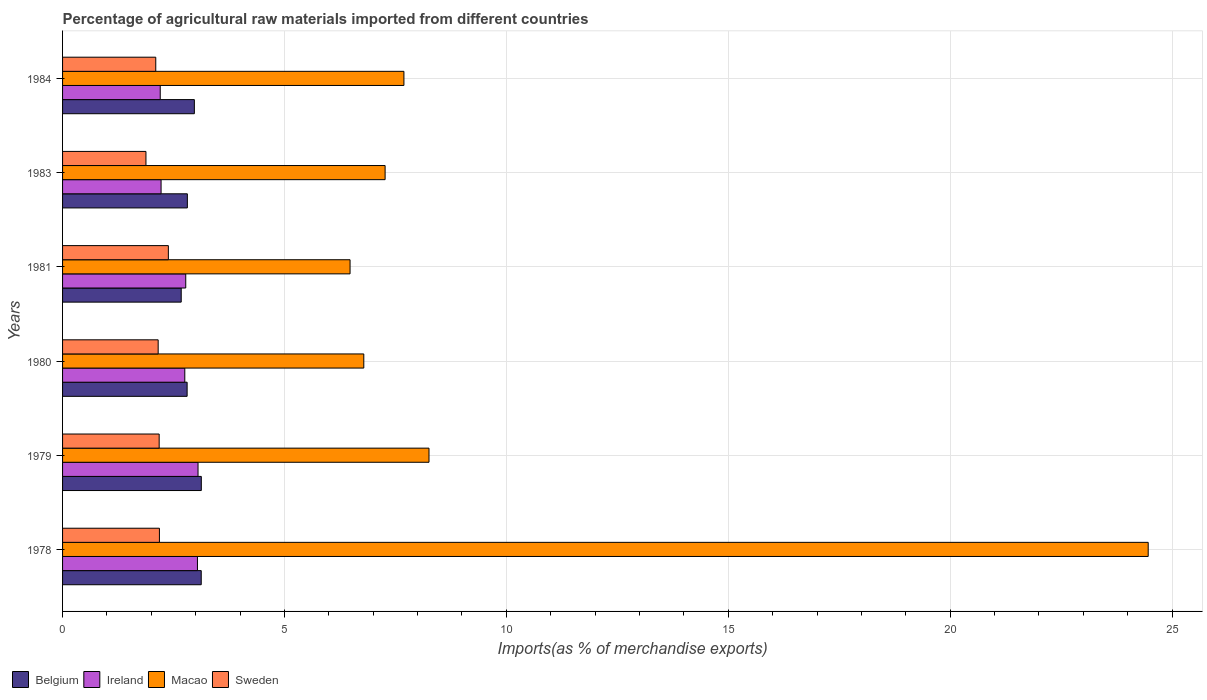How many different coloured bars are there?
Provide a short and direct response. 4. How many groups of bars are there?
Give a very brief answer. 6. Are the number of bars per tick equal to the number of legend labels?
Your response must be concise. Yes. Are the number of bars on each tick of the Y-axis equal?
Provide a short and direct response. Yes. What is the label of the 1st group of bars from the top?
Give a very brief answer. 1984. In how many cases, is the number of bars for a given year not equal to the number of legend labels?
Offer a terse response. 0. What is the percentage of imports to different countries in Macao in 1984?
Provide a short and direct response. 7.69. Across all years, what is the maximum percentage of imports to different countries in Belgium?
Offer a terse response. 3.13. Across all years, what is the minimum percentage of imports to different countries in Belgium?
Offer a terse response. 2.67. In which year was the percentage of imports to different countries in Belgium maximum?
Provide a short and direct response. 1979. In which year was the percentage of imports to different countries in Sweden minimum?
Provide a short and direct response. 1983. What is the total percentage of imports to different countries in Macao in the graph?
Offer a terse response. 60.94. What is the difference between the percentage of imports to different countries in Belgium in 1979 and that in 1980?
Your answer should be compact. 0.32. What is the difference between the percentage of imports to different countries in Macao in 1979 and the percentage of imports to different countries in Belgium in 1980?
Your response must be concise. 5.45. What is the average percentage of imports to different countries in Macao per year?
Ensure brevity in your answer.  10.16. In the year 1979, what is the difference between the percentage of imports to different countries in Belgium and percentage of imports to different countries in Ireland?
Give a very brief answer. 0.07. In how many years, is the percentage of imports to different countries in Macao greater than 21 %?
Ensure brevity in your answer.  1. What is the ratio of the percentage of imports to different countries in Ireland in 1978 to that in 1984?
Offer a terse response. 1.38. Is the percentage of imports to different countries in Ireland in 1979 less than that in 1980?
Provide a succinct answer. No. What is the difference between the highest and the second highest percentage of imports to different countries in Macao?
Your response must be concise. 16.21. What is the difference between the highest and the lowest percentage of imports to different countries in Sweden?
Give a very brief answer. 0.51. What does the 1st bar from the top in 1981 represents?
Keep it short and to the point. Sweden. What is the difference between two consecutive major ticks on the X-axis?
Offer a terse response. 5. Where does the legend appear in the graph?
Keep it short and to the point. Bottom left. What is the title of the graph?
Provide a succinct answer. Percentage of agricultural raw materials imported from different countries. What is the label or title of the X-axis?
Offer a terse response. Imports(as % of merchandise exports). What is the Imports(as % of merchandise exports) in Belgium in 1978?
Your answer should be compact. 3.12. What is the Imports(as % of merchandise exports) of Ireland in 1978?
Provide a succinct answer. 3.04. What is the Imports(as % of merchandise exports) in Macao in 1978?
Your answer should be very brief. 24.46. What is the Imports(as % of merchandise exports) in Sweden in 1978?
Make the answer very short. 2.18. What is the Imports(as % of merchandise exports) in Belgium in 1979?
Give a very brief answer. 3.13. What is the Imports(as % of merchandise exports) in Ireland in 1979?
Provide a succinct answer. 3.05. What is the Imports(as % of merchandise exports) in Macao in 1979?
Make the answer very short. 8.26. What is the Imports(as % of merchandise exports) in Sweden in 1979?
Keep it short and to the point. 2.18. What is the Imports(as % of merchandise exports) in Belgium in 1980?
Your response must be concise. 2.81. What is the Imports(as % of merchandise exports) of Ireland in 1980?
Give a very brief answer. 2.75. What is the Imports(as % of merchandise exports) in Macao in 1980?
Your answer should be very brief. 6.79. What is the Imports(as % of merchandise exports) in Sweden in 1980?
Provide a short and direct response. 2.15. What is the Imports(as % of merchandise exports) in Belgium in 1981?
Your answer should be very brief. 2.67. What is the Imports(as % of merchandise exports) of Ireland in 1981?
Your answer should be compact. 2.78. What is the Imports(as % of merchandise exports) of Macao in 1981?
Make the answer very short. 6.48. What is the Imports(as % of merchandise exports) in Sweden in 1981?
Your answer should be compact. 2.38. What is the Imports(as % of merchandise exports) in Belgium in 1983?
Offer a very short reply. 2.81. What is the Imports(as % of merchandise exports) in Ireland in 1983?
Keep it short and to the point. 2.22. What is the Imports(as % of merchandise exports) in Macao in 1983?
Provide a succinct answer. 7.27. What is the Imports(as % of merchandise exports) in Sweden in 1983?
Make the answer very short. 1.88. What is the Imports(as % of merchandise exports) of Belgium in 1984?
Ensure brevity in your answer.  2.97. What is the Imports(as % of merchandise exports) in Ireland in 1984?
Your answer should be very brief. 2.2. What is the Imports(as % of merchandise exports) in Macao in 1984?
Offer a terse response. 7.69. What is the Imports(as % of merchandise exports) of Sweden in 1984?
Your answer should be very brief. 2.1. Across all years, what is the maximum Imports(as % of merchandise exports) of Belgium?
Keep it short and to the point. 3.13. Across all years, what is the maximum Imports(as % of merchandise exports) in Ireland?
Offer a terse response. 3.05. Across all years, what is the maximum Imports(as % of merchandise exports) of Macao?
Offer a terse response. 24.46. Across all years, what is the maximum Imports(as % of merchandise exports) in Sweden?
Keep it short and to the point. 2.38. Across all years, what is the minimum Imports(as % of merchandise exports) of Belgium?
Offer a terse response. 2.67. Across all years, what is the minimum Imports(as % of merchandise exports) in Ireland?
Offer a terse response. 2.2. Across all years, what is the minimum Imports(as % of merchandise exports) of Macao?
Your answer should be very brief. 6.48. Across all years, what is the minimum Imports(as % of merchandise exports) of Sweden?
Ensure brevity in your answer.  1.88. What is the total Imports(as % of merchandise exports) of Belgium in the graph?
Provide a succinct answer. 17.51. What is the total Imports(as % of merchandise exports) in Ireland in the graph?
Your answer should be compact. 16.04. What is the total Imports(as % of merchandise exports) in Macao in the graph?
Keep it short and to the point. 60.94. What is the total Imports(as % of merchandise exports) in Sweden in the graph?
Ensure brevity in your answer.  12.88. What is the difference between the Imports(as % of merchandise exports) of Belgium in 1978 and that in 1979?
Your answer should be very brief. -0. What is the difference between the Imports(as % of merchandise exports) of Ireland in 1978 and that in 1979?
Your answer should be very brief. -0.01. What is the difference between the Imports(as % of merchandise exports) in Macao in 1978 and that in 1979?
Keep it short and to the point. 16.21. What is the difference between the Imports(as % of merchandise exports) of Sweden in 1978 and that in 1979?
Provide a short and direct response. 0.01. What is the difference between the Imports(as % of merchandise exports) of Belgium in 1978 and that in 1980?
Ensure brevity in your answer.  0.32. What is the difference between the Imports(as % of merchandise exports) of Ireland in 1978 and that in 1980?
Provide a succinct answer. 0.29. What is the difference between the Imports(as % of merchandise exports) of Macao in 1978 and that in 1980?
Give a very brief answer. 17.67. What is the difference between the Imports(as % of merchandise exports) of Sweden in 1978 and that in 1980?
Make the answer very short. 0.03. What is the difference between the Imports(as % of merchandise exports) of Belgium in 1978 and that in 1981?
Provide a succinct answer. 0.45. What is the difference between the Imports(as % of merchandise exports) of Ireland in 1978 and that in 1981?
Offer a very short reply. 0.26. What is the difference between the Imports(as % of merchandise exports) of Macao in 1978 and that in 1981?
Make the answer very short. 17.98. What is the difference between the Imports(as % of merchandise exports) in Sweden in 1978 and that in 1981?
Offer a very short reply. -0.2. What is the difference between the Imports(as % of merchandise exports) of Belgium in 1978 and that in 1983?
Your answer should be very brief. 0.31. What is the difference between the Imports(as % of merchandise exports) in Ireland in 1978 and that in 1983?
Provide a short and direct response. 0.82. What is the difference between the Imports(as % of merchandise exports) of Macao in 1978 and that in 1983?
Your answer should be very brief. 17.19. What is the difference between the Imports(as % of merchandise exports) in Sweden in 1978 and that in 1983?
Your response must be concise. 0.3. What is the difference between the Imports(as % of merchandise exports) of Belgium in 1978 and that in 1984?
Keep it short and to the point. 0.15. What is the difference between the Imports(as % of merchandise exports) of Ireland in 1978 and that in 1984?
Make the answer very short. 0.84. What is the difference between the Imports(as % of merchandise exports) in Macao in 1978 and that in 1984?
Your answer should be compact. 16.77. What is the difference between the Imports(as % of merchandise exports) in Sweden in 1978 and that in 1984?
Provide a short and direct response. 0.08. What is the difference between the Imports(as % of merchandise exports) in Belgium in 1979 and that in 1980?
Ensure brevity in your answer.  0.32. What is the difference between the Imports(as % of merchandise exports) of Ireland in 1979 and that in 1980?
Give a very brief answer. 0.3. What is the difference between the Imports(as % of merchandise exports) of Macao in 1979 and that in 1980?
Keep it short and to the point. 1.47. What is the difference between the Imports(as % of merchandise exports) of Sweden in 1979 and that in 1980?
Your response must be concise. 0.02. What is the difference between the Imports(as % of merchandise exports) in Belgium in 1979 and that in 1981?
Offer a very short reply. 0.45. What is the difference between the Imports(as % of merchandise exports) in Ireland in 1979 and that in 1981?
Your answer should be compact. 0.28. What is the difference between the Imports(as % of merchandise exports) in Macao in 1979 and that in 1981?
Make the answer very short. 1.78. What is the difference between the Imports(as % of merchandise exports) of Sweden in 1979 and that in 1981?
Your answer should be very brief. -0.21. What is the difference between the Imports(as % of merchandise exports) in Belgium in 1979 and that in 1983?
Offer a terse response. 0.31. What is the difference between the Imports(as % of merchandise exports) of Ireland in 1979 and that in 1983?
Offer a very short reply. 0.83. What is the difference between the Imports(as % of merchandise exports) of Sweden in 1979 and that in 1983?
Provide a short and direct response. 0.3. What is the difference between the Imports(as % of merchandise exports) in Belgium in 1979 and that in 1984?
Your answer should be compact. 0.16. What is the difference between the Imports(as % of merchandise exports) in Ireland in 1979 and that in 1984?
Ensure brevity in your answer.  0.85. What is the difference between the Imports(as % of merchandise exports) in Macao in 1979 and that in 1984?
Your response must be concise. 0.57. What is the difference between the Imports(as % of merchandise exports) of Sweden in 1979 and that in 1984?
Offer a terse response. 0.08. What is the difference between the Imports(as % of merchandise exports) in Belgium in 1980 and that in 1981?
Keep it short and to the point. 0.13. What is the difference between the Imports(as % of merchandise exports) in Ireland in 1980 and that in 1981?
Offer a terse response. -0.02. What is the difference between the Imports(as % of merchandise exports) in Macao in 1980 and that in 1981?
Your answer should be compact. 0.31. What is the difference between the Imports(as % of merchandise exports) of Sweden in 1980 and that in 1981?
Offer a terse response. -0.23. What is the difference between the Imports(as % of merchandise exports) in Belgium in 1980 and that in 1983?
Give a very brief answer. -0.01. What is the difference between the Imports(as % of merchandise exports) in Ireland in 1980 and that in 1983?
Ensure brevity in your answer.  0.53. What is the difference between the Imports(as % of merchandise exports) in Macao in 1980 and that in 1983?
Keep it short and to the point. -0.48. What is the difference between the Imports(as % of merchandise exports) in Sweden in 1980 and that in 1983?
Your answer should be very brief. 0.28. What is the difference between the Imports(as % of merchandise exports) of Belgium in 1980 and that in 1984?
Provide a short and direct response. -0.16. What is the difference between the Imports(as % of merchandise exports) in Ireland in 1980 and that in 1984?
Your response must be concise. 0.55. What is the difference between the Imports(as % of merchandise exports) of Macao in 1980 and that in 1984?
Ensure brevity in your answer.  -0.9. What is the difference between the Imports(as % of merchandise exports) of Sweden in 1980 and that in 1984?
Your answer should be compact. 0.05. What is the difference between the Imports(as % of merchandise exports) in Belgium in 1981 and that in 1983?
Offer a terse response. -0.14. What is the difference between the Imports(as % of merchandise exports) of Ireland in 1981 and that in 1983?
Keep it short and to the point. 0.56. What is the difference between the Imports(as % of merchandise exports) in Macao in 1981 and that in 1983?
Your answer should be very brief. -0.79. What is the difference between the Imports(as % of merchandise exports) of Sweden in 1981 and that in 1983?
Give a very brief answer. 0.51. What is the difference between the Imports(as % of merchandise exports) in Belgium in 1981 and that in 1984?
Give a very brief answer. -0.3. What is the difference between the Imports(as % of merchandise exports) of Ireland in 1981 and that in 1984?
Provide a short and direct response. 0.58. What is the difference between the Imports(as % of merchandise exports) of Macao in 1981 and that in 1984?
Make the answer very short. -1.21. What is the difference between the Imports(as % of merchandise exports) in Sweden in 1981 and that in 1984?
Your response must be concise. 0.28. What is the difference between the Imports(as % of merchandise exports) of Belgium in 1983 and that in 1984?
Offer a very short reply. -0.16. What is the difference between the Imports(as % of merchandise exports) of Ireland in 1983 and that in 1984?
Your response must be concise. 0.02. What is the difference between the Imports(as % of merchandise exports) in Macao in 1983 and that in 1984?
Keep it short and to the point. -0.42. What is the difference between the Imports(as % of merchandise exports) in Sweden in 1983 and that in 1984?
Offer a terse response. -0.22. What is the difference between the Imports(as % of merchandise exports) of Belgium in 1978 and the Imports(as % of merchandise exports) of Ireland in 1979?
Ensure brevity in your answer.  0.07. What is the difference between the Imports(as % of merchandise exports) of Belgium in 1978 and the Imports(as % of merchandise exports) of Macao in 1979?
Make the answer very short. -5.13. What is the difference between the Imports(as % of merchandise exports) in Belgium in 1978 and the Imports(as % of merchandise exports) in Sweden in 1979?
Keep it short and to the point. 0.95. What is the difference between the Imports(as % of merchandise exports) in Ireland in 1978 and the Imports(as % of merchandise exports) in Macao in 1979?
Provide a short and direct response. -5.22. What is the difference between the Imports(as % of merchandise exports) in Ireland in 1978 and the Imports(as % of merchandise exports) in Sweden in 1979?
Give a very brief answer. 0.86. What is the difference between the Imports(as % of merchandise exports) of Macao in 1978 and the Imports(as % of merchandise exports) of Sweden in 1979?
Ensure brevity in your answer.  22.29. What is the difference between the Imports(as % of merchandise exports) in Belgium in 1978 and the Imports(as % of merchandise exports) in Ireland in 1980?
Provide a succinct answer. 0.37. What is the difference between the Imports(as % of merchandise exports) in Belgium in 1978 and the Imports(as % of merchandise exports) in Macao in 1980?
Your answer should be compact. -3.66. What is the difference between the Imports(as % of merchandise exports) in Belgium in 1978 and the Imports(as % of merchandise exports) in Sweden in 1980?
Your answer should be very brief. 0.97. What is the difference between the Imports(as % of merchandise exports) of Ireland in 1978 and the Imports(as % of merchandise exports) of Macao in 1980?
Offer a terse response. -3.75. What is the difference between the Imports(as % of merchandise exports) in Ireland in 1978 and the Imports(as % of merchandise exports) in Sweden in 1980?
Offer a terse response. 0.89. What is the difference between the Imports(as % of merchandise exports) in Macao in 1978 and the Imports(as % of merchandise exports) in Sweden in 1980?
Keep it short and to the point. 22.31. What is the difference between the Imports(as % of merchandise exports) of Belgium in 1978 and the Imports(as % of merchandise exports) of Ireland in 1981?
Provide a short and direct response. 0.35. What is the difference between the Imports(as % of merchandise exports) in Belgium in 1978 and the Imports(as % of merchandise exports) in Macao in 1981?
Ensure brevity in your answer.  -3.35. What is the difference between the Imports(as % of merchandise exports) of Belgium in 1978 and the Imports(as % of merchandise exports) of Sweden in 1981?
Your answer should be very brief. 0.74. What is the difference between the Imports(as % of merchandise exports) of Ireland in 1978 and the Imports(as % of merchandise exports) of Macao in 1981?
Your answer should be compact. -3.44. What is the difference between the Imports(as % of merchandise exports) in Ireland in 1978 and the Imports(as % of merchandise exports) in Sweden in 1981?
Make the answer very short. 0.66. What is the difference between the Imports(as % of merchandise exports) in Macao in 1978 and the Imports(as % of merchandise exports) in Sweden in 1981?
Ensure brevity in your answer.  22.08. What is the difference between the Imports(as % of merchandise exports) of Belgium in 1978 and the Imports(as % of merchandise exports) of Ireland in 1983?
Make the answer very short. 0.9. What is the difference between the Imports(as % of merchandise exports) in Belgium in 1978 and the Imports(as % of merchandise exports) in Macao in 1983?
Make the answer very short. -4.14. What is the difference between the Imports(as % of merchandise exports) of Belgium in 1978 and the Imports(as % of merchandise exports) of Sweden in 1983?
Ensure brevity in your answer.  1.25. What is the difference between the Imports(as % of merchandise exports) in Ireland in 1978 and the Imports(as % of merchandise exports) in Macao in 1983?
Give a very brief answer. -4.23. What is the difference between the Imports(as % of merchandise exports) in Ireland in 1978 and the Imports(as % of merchandise exports) in Sweden in 1983?
Keep it short and to the point. 1.16. What is the difference between the Imports(as % of merchandise exports) of Macao in 1978 and the Imports(as % of merchandise exports) of Sweden in 1983?
Keep it short and to the point. 22.58. What is the difference between the Imports(as % of merchandise exports) of Belgium in 1978 and the Imports(as % of merchandise exports) of Ireland in 1984?
Provide a succinct answer. 0.92. What is the difference between the Imports(as % of merchandise exports) of Belgium in 1978 and the Imports(as % of merchandise exports) of Macao in 1984?
Your answer should be very brief. -4.57. What is the difference between the Imports(as % of merchandise exports) of Belgium in 1978 and the Imports(as % of merchandise exports) of Sweden in 1984?
Give a very brief answer. 1.02. What is the difference between the Imports(as % of merchandise exports) of Ireland in 1978 and the Imports(as % of merchandise exports) of Macao in 1984?
Make the answer very short. -4.65. What is the difference between the Imports(as % of merchandise exports) in Ireland in 1978 and the Imports(as % of merchandise exports) in Sweden in 1984?
Provide a succinct answer. 0.94. What is the difference between the Imports(as % of merchandise exports) of Macao in 1978 and the Imports(as % of merchandise exports) of Sweden in 1984?
Offer a terse response. 22.36. What is the difference between the Imports(as % of merchandise exports) of Belgium in 1979 and the Imports(as % of merchandise exports) of Ireland in 1980?
Your response must be concise. 0.37. What is the difference between the Imports(as % of merchandise exports) of Belgium in 1979 and the Imports(as % of merchandise exports) of Macao in 1980?
Make the answer very short. -3.66. What is the difference between the Imports(as % of merchandise exports) of Belgium in 1979 and the Imports(as % of merchandise exports) of Sweden in 1980?
Provide a succinct answer. 0.97. What is the difference between the Imports(as % of merchandise exports) in Ireland in 1979 and the Imports(as % of merchandise exports) in Macao in 1980?
Offer a very short reply. -3.74. What is the difference between the Imports(as % of merchandise exports) of Ireland in 1979 and the Imports(as % of merchandise exports) of Sweden in 1980?
Make the answer very short. 0.9. What is the difference between the Imports(as % of merchandise exports) of Macao in 1979 and the Imports(as % of merchandise exports) of Sweden in 1980?
Offer a terse response. 6.1. What is the difference between the Imports(as % of merchandise exports) in Belgium in 1979 and the Imports(as % of merchandise exports) in Ireland in 1981?
Your answer should be very brief. 0.35. What is the difference between the Imports(as % of merchandise exports) of Belgium in 1979 and the Imports(as % of merchandise exports) of Macao in 1981?
Your answer should be compact. -3.35. What is the difference between the Imports(as % of merchandise exports) in Belgium in 1979 and the Imports(as % of merchandise exports) in Sweden in 1981?
Give a very brief answer. 0.74. What is the difference between the Imports(as % of merchandise exports) of Ireland in 1979 and the Imports(as % of merchandise exports) of Macao in 1981?
Keep it short and to the point. -3.43. What is the difference between the Imports(as % of merchandise exports) of Ireland in 1979 and the Imports(as % of merchandise exports) of Sweden in 1981?
Your response must be concise. 0.67. What is the difference between the Imports(as % of merchandise exports) of Macao in 1979 and the Imports(as % of merchandise exports) of Sweden in 1981?
Provide a succinct answer. 5.87. What is the difference between the Imports(as % of merchandise exports) in Belgium in 1979 and the Imports(as % of merchandise exports) in Ireland in 1983?
Your answer should be very brief. 0.91. What is the difference between the Imports(as % of merchandise exports) in Belgium in 1979 and the Imports(as % of merchandise exports) in Macao in 1983?
Your answer should be compact. -4.14. What is the difference between the Imports(as % of merchandise exports) of Belgium in 1979 and the Imports(as % of merchandise exports) of Sweden in 1983?
Offer a very short reply. 1.25. What is the difference between the Imports(as % of merchandise exports) of Ireland in 1979 and the Imports(as % of merchandise exports) of Macao in 1983?
Offer a terse response. -4.22. What is the difference between the Imports(as % of merchandise exports) of Ireland in 1979 and the Imports(as % of merchandise exports) of Sweden in 1983?
Your answer should be compact. 1.17. What is the difference between the Imports(as % of merchandise exports) of Macao in 1979 and the Imports(as % of merchandise exports) of Sweden in 1983?
Keep it short and to the point. 6.38. What is the difference between the Imports(as % of merchandise exports) in Belgium in 1979 and the Imports(as % of merchandise exports) in Ireland in 1984?
Make the answer very short. 0.93. What is the difference between the Imports(as % of merchandise exports) of Belgium in 1979 and the Imports(as % of merchandise exports) of Macao in 1984?
Provide a succinct answer. -4.57. What is the difference between the Imports(as % of merchandise exports) of Belgium in 1979 and the Imports(as % of merchandise exports) of Sweden in 1984?
Ensure brevity in your answer.  1.03. What is the difference between the Imports(as % of merchandise exports) of Ireland in 1979 and the Imports(as % of merchandise exports) of Macao in 1984?
Keep it short and to the point. -4.64. What is the difference between the Imports(as % of merchandise exports) in Ireland in 1979 and the Imports(as % of merchandise exports) in Sweden in 1984?
Make the answer very short. 0.95. What is the difference between the Imports(as % of merchandise exports) in Macao in 1979 and the Imports(as % of merchandise exports) in Sweden in 1984?
Offer a terse response. 6.16. What is the difference between the Imports(as % of merchandise exports) of Belgium in 1980 and the Imports(as % of merchandise exports) of Ireland in 1981?
Provide a short and direct response. 0.03. What is the difference between the Imports(as % of merchandise exports) in Belgium in 1980 and the Imports(as % of merchandise exports) in Macao in 1981?
Offer a very short reply. -3.67. What is the difference between the Imports(as % of merchandise exports) of Belgium in 1980 and the Imports(as % of merchandise exports) of Sweden in 1981?
Give a very brief answer. 0.42. What is the difference between the Imports(as % of merchandise exports) of Ireland in 1980 and the Imports(as % of merchandise exports) of Macao in 1981?
Your answer should be very brief. -3.72. What is the difference between the Imports(as % of merchandise exports) of Ireland in 1980 and the Imports(as % of merchandise exports) of Sweden in 1981?
Provide a short and direct response. 0.37. What is the difference between the Imports(as % of merchandise exports) in Macao in 1980 and the Imports(as % of merchandise exports) in Sweden in 1981?
Provide a succinct answer. 4.4. What is the difference between the Imports(as % of merchandise exports) of Belgium in 1980 and the Imports(as % of merchandise exports) of Ireland in 1983?
Provide a succinct answer. 0.59. What is the difference between the Imports(as % of merchandise exports) of Belgium in 1980 and the Imports(as % of merchandise exports) of Macao in 1983?
Ensure brevity in your answer.  -4.46. What is the difference between the Imports(as % of merchandise exports) in Belgium in 1980 and the Imports(as % of merchandise exports) in Sweden in 1983?
Your answer should be very brief. 0.93. What is the difference between the Imports(as % of merchandise exports) in Ireland in 1980 and the Imports(as % of merchandise exports) in Macao in 1983?
Make the answer very short. -4.51. What is the difference between the Imports(as % of merchandise exports) in Ireland in 1980 and the Imports(as % of merchandise exports) in Sweden in 1983?
Keep it short and to the point. 0.88. What is the difference between the Imports(as % of merchandise exports) in Macao in 1980 and the Imports(as % of merchandise exports) in Sweden in 1983?
Offer a very short reply. 4.91. What is the difference between the Imports(as % of merchandise exports) of Belgium in 1980 and the Imports(as % of merchandise exports) of Ireland in 1984?
Make the answer very short. 0.61. What is the difference between the Imports(as % of merchandise exports) in Belgium in 1980 and the Imports(as % of merchandise exports) in Macao in 1984?
Provide a succinct answer. -4.88. What is the difference between the Imports(as % of merchandise exports) of Belgium in 1980 and the Imports(as % of merchandise exports) of Sweden in 1984?
Your response must be concise. 0.71. What is the difference between the Imports(as % of merchandise exports) in Ireland in 1980 and the Imports(as % of merchandise exports) in Macao in 1984?
Provide a succinct answer. -4.94. What is the difference between the Imports(as % of merchandise exports) of Ireland in 1980 and the Imports(as % of merchandise exports) of Sweden in 1984?
Offer a terse response. 0.65. What is the difference between the Imports(as % of merchandise exports) in Macao in 1980 and the Imports(as % of merchandise exports) in Sweden in 1984?
Your response must be concise. 4.69. What is the difference between the Imports(as % of merchandise exports) of Belgium in 1981 and the Imports(as % of merchandise exports) of Ireland in 1983?
Offer a terse response. 0.45. What is the difference between the Imports(as % of merchandise exports) in Belgium in 1981 and the Imports(as % of merchandise exports) in Macao in 1983?
Give a very brief answer. -4.59. What is the difference between the Imports(as % of merchandise exports) in Belgium in 1981 and the Imports(as % of merchandise exports) in Sweden in 1983?
Give a very brief answer. 0.79. What is the difference between the Imports(as % of merchandise exports) in Ireland in 1981 and the Imports(as % of merchandise exports) in Macao in 1983?
Offer a very short reply. -4.49. What is the difference between the Imports(as % of merchandise exports) of Ireland in 1981 and the Imports(as % of merchandise exports) of Sweden in 1983?
Your answer should be very brief. 0.9. What is the difference between the Imports(as % of merchandise exports) of Macao in 1981 and the Imports(as % of merchandise exports) of Sweden in 1983?
Offer a very short reply. 4.6. What is the difference between the Imports(as % of merchandise exports) of Belgium in 1981 and the Imports(as % of merchandise exports) of Ireland in 1984?
Make the answer very short. 0.47. What is the difference between the Imports(as % of merchandise exports) of Belgium in 1981 and the Imports(as % of merchandise exports) of Macao in 1984?
Offer a very short reply. -5.02. What is the difference between the Imports(as % of merchandise exports) of Belgium in 1981 and the Imports(as % of merchandise exports) of Sweden in 1984?
Make the answer very short. 0.57. What is the difference between the Imports(as % of merchandise exports) in Ireland in 1981 and the Imports(as % of merchandise exports) in Macao in 1984?
Provide a succinct answer. -4.92. What is the difference between the Imports(as % of merchandise exports) of Ireland in 1981 and the Imports(as % of merchandise exports) of Sweden in 1984?
Ensure brevity in your answer.  0.68. What is the difference between the Imports(as % of merchandise exports) of Macao in 1981 and the Imports(as % of merchandise exports) of Sweden in 1984?
Provide a short and direct response. 4.38. What is the difference between the Imports(as % of merchandise exports) of Belgium in 1983 and the Imports(as % of merchandise exports) of Ireland in 1984?
Provide a short and direct response. 0.61. What is the difference between the Imports(as % of merchandise exports) of Belgium in 1983 and the Imports(as % of merchandise exports) of Macao in 1984?
Ensure brevity in your answer.  -4.88. What is the difference between the Imports(as % of merchandise exports) of Belgium in 1983 and the Imports(as % of merchandise exports) of Sweden in 1984?
Your answer should be compact. 0.71. What is the difference between the Imports(as % of merchandise exports) in Ireland in 1983 and the Imports(as % of merchandise exports) in Macao in 1984?
Keep it short and to the point. -5.47. What is the difference between the Imports(as % of merchandise exports) in Ireland in 1983 and the Imports(as % of merchandise exports) in Sweden in 1984?
Make the answer very short. 0.12. What is the difference between the Imports(as % of merchandise exports) of Macao in 1983 and the Imports(as % of merchandise exports) of Sweden in 1984?
Ensure brevity in your answer.  5.17. What is the average Imports(as % of merchandise exports) of Belgium per year?
Your response must be concise. 2.92. What is the average Imports(as % of merchandise exports) of Ireland per year?
Your answer should be compact. 2.67. What is the average Imports(as % of merchandise exports) in Macao per year?
Offer a very short reply. 10.16. What is the average Imports(as % of merchandise exports) in Sweden per year?
Offer a very short reply. 2.15. In the year 1978, what is the difference between the Imports(as % of merchandise exports) of Belgium and Imports(as % of merchandise exports) of Ireland?
Your answer should be very brief. 0.09. In the year 1978, what is the difference between the Imports(as % of merchandise exports) of Belgium and Imports(as % of merchandise exports) of Macao?
Make the answer very short. -21.34. In the year 1978, what is the difference between the Imports(as % of merchandise exports) in Belgium and Imports(as % of merchandise exports) in Sweden?
Your answer should be compact. 0.94. In the year 1978, what is the difference between the Imports(as % of merchandise exports) of Ireland and Imports(as % of merchandise exports) of Macao?
Offer a terse response. -21.42. In the year 1978, what is the difference between the Imports(as % of merchandise exports) of Ireland and Imports(as % of merchandise exports) of Sweden?
Offer a terse response. 0.86. In the year 1978, what is the difference between the Imports(as % of merchandise exports) of Macao and Imports(as % of merchandise exports) of Sweden?
Your answer should be compact. 22.28. In the year 1979, what is the difference between the Imports(as % of merchandise exports) in Belgium and Imports(as % of merchandise exports) in Ireland?
Make the answer very short. 0.07. In the year 1979, what is the difference between the Imports(as % of merchandise exports) of Belgium and Imports(as % of merchandise exports) of Macao?
Offer a very short reply. -5.13. In the year 1979, what is the difference between the Imports(as % of merchandise exports) of Belgium and Imports(as % of merchandise exports) of Sweden?
Your response must be concise. 0.95. In the year 1979, what is the difference between the Imports(as % of merchandise exports) in Ireland and Imports(as % of merchandise exports) in Macao?
Offer a very short reply. -5.2. In the year 1979, what is the difference between the Imports(as % of merchandise exports) in Ireland and Imports(as % of merchandise exports) in Sweden?
Offer a very short reply. 0.88. In the year 1979, what is the difference between the Imports(as % of merchandise exports) of Macao and Imports(as % of merchandise exports) of Sweden?
Give a very brief answer. 6.08. In the year 1980, what is the difference between the Imports(as % of merchandise exports) of Belgium and Imports(as % of merchandise exports) of Ireland?
Your answer should be very brief. 0.05. In the year 1980, what is the difference between the Imports(as % of merchandise exports) in Belgium and Imports(as % of merchandise exports) in Macao?
Offer a terse response. -3.98. In the year 1980, what is the difference between the Imports(as % of merchandise exports) of Belgium and Imports(as % of merchandise exports) of Sweden?
Provide a succinct answer. 0.65. In the year 1980, what is the difference between the Imports(as % of merchandise exports) of Ireland and Imports(as % of merchandise exports) of Macao?
Keep it short and to the point. -4.03. In the year 1980, what is the difference between the Imports(as % of merchandise exports) of Ireland and Imports(as % of merchandise exports) of Sweden?
Your answer should be compact. 0.6. In the year 1980, what is the difference between the Imports(as % of merchandise exports) in Macao and Imports(as % of merchandise exports) in Sweden?
Provide a succinct answer. 4.63. In the year 1981, what is the difference between the Imports(as % of merchandise exports) of Belgium and Imports(as % of merchandise exports) of Ireland?
Your answer should be very brief. -0.1. In the year 1981, what is the difference between the Imports(as % of merchandise exports) of Belgium and Imports(as % of merchandise exports) of Macao?
Give a very brief answer. -3.8. In the year 1981, what is the difference between the Imports(as % of merchandise exports) in Belgium and Imports(as % of merchandise exports) in Sweden?
Your answer should be compact. 0.29. In the year 1981, what is the difference between the Imports(as % of merchandise exports) of Ireland and Imports(as % of merchandise exports) of Macao?
Keep it short and to the point. -3.7. In the year 1981, what is the difference between the Imports(as % of merchandise exports) in Ireland and Imports(as % of merchandise exports) in Sweden?
Provide a succinct answer. 0.39. In the year 1981, what is the difference between the Imports(as % of merchandise exports) in Macao and Imports(as % of merchandise exports) in Sweden?
Offer a very short reply. 4.09. In the year 1983, what is the difference between the Imports(as % of merchandise exports) in Belgium and Imports(as % of merchandise exports) in Ireland?
Your answer should be compact. 0.59. In the year 1983, what is the difference between the Imports(as % of merchandise exports) of Belgium and Imports(as % of merchandise exports) of Macao?
Offer a very short reply. -4.46. In the year 1983, what is the difference between the Imports(as % of merchandise exports) in Belgium and Imports(as % of merchandise exports) in Sweden?
Ensure brevity in your answer.  0.93. In the year 1983, what is the difference between the Imports(as % of merchandise exports) in Ireland and Imports(as % of merchandise exports) in Macao?
Your answer should be compact. -5.05. In the year 1983, what is the difference between the Imports(as % of merchandise exports) of Ireland and Imports(as % of merchandise exports) of Sweden?
Your answer should be compact. 0.34. In the year 1983, what is the difference between the Imports(as % of merchandise exports) in Macao and Imports(as % of merchandise exports) in Sweden?
Ensure brevity in your answer.  5.39. In the year 1984, what is the difference between the Imports(as % of merchandise exports) of Belgium and Imports(as % of merchandise exports) of Ireland?
Your response must be concise. 0.77. In the year 1984, what is the difference between the Imports(as % of merchandise exports) of Belgium and Imports(as % of merchandise exports) of Macao?
Provide a short and direct response. -4.72. In the year 1984, what is the difference between the Imports(as % of merchandise exports) in Belgium and Imports(as % of merchandise exports) in Sweden?
Provide a succinct answer. 0.87. In the year 1984, what is the difference between the Imports(as % of merchandise exports) of Ireland and Imports(as % of merchandise exports) of Macao?
Provide a short and direct response. -5.49. In the year 1984, what is the difference between the Imports(as % of merchandise exports) of Ireland and Imports(as % of merchandise exports) of Sweden?
Offer a very short reply. 0.1. In the year 1984, what is the difference between the Imports(as % of merchandise exports) in Macao and Imports(as % of merchandise exports) in Sweden?
Provide a succinct answer. 5.59. What is the ratio of the Imports(as % of merchandise exports) of Belgium in 1978 to that in 1979?
Your response must be concise. 1. What is the ratio of the Imports(as % of merchandise exports) of Ireland in 1978 to that in 1979?
Provide a succinct answer. 1. What is the ratio of the Imports(as % of merchandise exports) of Macao in 1978 to that in 1979?
Offer a terse response. 2.96. What is the ratio of the Imports(as % of merchandise exports) in Sweden in 1978 to that in 1979?
Ensure brevity in your answer.  1. What is the ratio of the Imports(as % of merchandise exports) of Belgium in 1978 to that in 1980?
Offer a terse response. 1.11. What is the ratio of the Imports(as % of merchandise exports) in Ireland in 1978 to that in 1980?
Make the answer very short. 1.1. What is the ratio of the Imports(as % of merchandise exports) of Macao in 1978 to that in 1980?
Keep it short and to the point. 3.6. What is the ratio of the Imports(as % of merchandise exports) of Sweden in 1978 to that in 1980?
Make the answer very short. 1.01. What is the ratio of the Imports(as % of merchandise exports) of Belgium in 1978 to that in 1981?
Your answer should be very brief. 1.17. What is the ratio of the Imports(as % of merchandise exports) of Ireland in 1978 to that in 1981?
Offer a terse response. 1.09. What is the ratio of the Imports(as % of merchandise exports) in Macao in 1978 to that in 1981?
Make the answer very short. 3.78. What is the ratio of the Imports(as % of merchandise exports) in Sweden in 1978 to that in 1981?
Provide a succinct answer. 0.92. What is the ratio of the Imports(as % of merchandise exports) of Belgium in 1978 to that in 1983?
Provide a succinct answer. 1.11. What is the ratio of the Imports(as % of merchandise exports) in Ireland in 1978 to that in 1983?
Your answer should be very brief. 1.37. What is the ratio of the Imports(as % of merchandise exports) of Macao in 1978 to that in 1983?
Your response must be concise. 3.37. What is the ratio of the Imports(as % of merchandise exports) of Sweden in 1978 to that in 1983?
Your answer should be very brief. 1.16. What is the ratio of the Imports(as % of merchandise exports) of Belgium in 1978 to that in 1984?
Your response must be concise. 1.05. What is the ratio of the Imports(as % of merchandise exports) of Ireland in 1978 to that in 1984?
Ensure brevity in your answer.  1.38. What is the ratio of the Imports(as % of merchandise exports) in Macao in 1978 to that in 1984?
Give a very brief answer. 3.18. What is the ratio of the Imports(as % of merchandise exports) in Sweden in 1978 to that in 1984?
Make the answer very short. 1.04. What is the ratio of the Imports(as % of merchandise exports) of Belgium in 1979 to that in 1980?
Offer a very short reply. 1.11. What is the ratio of the Imports(as % of merchandise exports) in Ireland in 1979 to that in 1980?
Provide a short and direct response. 1.11. What is the ratio of the Imports(as % of merchandise exports) of Macao in 1979 to that in 1980?
Provide a succinct answer. 1.22. What is the ratio of the Imports(as % of merchandise exports) in Sweden in 1979 to that in 1980?
Your answer should be compact. 1.01. What is the ratio of the Imports(as % of merchandise exports) of Belgium in 1979 to that in 1981?
Ensure brevity in your answer.  1.17. What is the ratio of the Imports(as % of merchandise exports) of Ireland in 1979 to that in 1981?
Your answer should be compact. 1.1. What is the ratio of the Imports(as % of merchandise exports) of Macao in 1979 to that in 1981?
Provide a short and direct response. 1.27. What is the ratio of the Imports(as % of merchandise exports) in Sweden in 1979 to that in 1981?
Your answer should be compact. 0.91. What is the ratio of the Imports(as % of merchandise exports) in Belgium in 1979 to that in 1983?
Make the answer very short. 1.11. What is the ratio of the Imports(as % of merchandise exports) in Ireland in 1979 to that in 1983?
Offer a very short reply. 1.38. What is the ratio of the Imports(as % of merchandise exports) of Macao in 1979 to that in 1983?
Your answer should be compact. 1.14. What is the ratio of the Imports(as % of merchandise exports) of Sweden in 1979 to that in 1983?
Make the answer very short. 1.16. What is the ratio of the Imports(as % of merchandise exports) of Belgium in 1979 to that in 1984?
Offer a terse response. 1.05. What is the ratio of the Imports(as % of merchandise exports) in Ireland in 1979 to that in 1984?
Ensure brevity in your answer.  1.39. What is the ratio of the Imports(as % of merchandise exports) of Macao in 1979 to that in 1984?
Ensure brevity in your answer.  1.07. What is the ratio of the Imports(as % of merchandise exports) in Sweden in 1979 to that in 1984?
Make the answer very short. 1.04. What is the ratio of the Imports(as % of merchandise exports) of Belgium in 1980 to that in 1981?
Give a very brief answer. 1.05. What is the ratio of the Imports(as % of merchandise exports) of Macao in 1980 to that in 1981?
Your response must be concise. 1.05. What is the ratio of the Imports(as % of merchandise exports) in Sweden in 1980 to that in 1981?
Make the answer very short. 0.9. What is the ratio of the Imports(as % of merchandise exports) in Belgium in 1980 to that in 1983?
Keep it short and to the point. 1. What is the ratio of the Imports(as % of merchandise exports) in Ireland in 1980 to that in 1983?
Give a very brief answer. 1.24. What is the ratio of the Imports(as % of merchandise exports) of Macao in 1980 to that in 1983?
Provide a succinct answer. 0.93. What is the ratio of the Imports(as % of merchandise exports) of Sweden in 1980 to that in 1983?
Offer a terse response. 1.15. What is the ratio of the Imports(as % of merchandise exports) in Belgium in 1980 to that in 1984?
Your answer should be compact. 0.95. What is the ratio of the Imports(as % of merchandise exports) of Ireland in 1980 to that in 1984?
Your answer should be compact. 1.25. What is the ratio of the Imports(as % of merchandise exports) in Macao in 1980 to that in 1984?
Provide a short and direct response. 0.88. What is the ratio of the Imports(as % of merchandise exports) of Sweden in 1980 to that in 1984?
Offer a very short reply. 1.03. What is the ratio of the Imports(as % of merchandise exports) of Belgium in 1981 to that in 1983?
Your response must be concise. 0.95. What is the ratio of the Imports(as % of merchandise exports) in Ireland in 1981 to that in 1983?
Keep it short and to the point. 1.25. What is the ratio of the Imports(as % of merchandise exports) of Macao in 1981 to that in 1983?
Your answer should be very brief. 0.89. What is the ratio of the Imports(as % of merchandise exports) of Sweden in 1981 to that in 1983?
Your response must be concise. 1.27. What is the ratio of the Imports(as % of merchandise exports) of Belgium in 1981 to that in 1984?
Your answer should be very brief. 0.9. What is the ratio of the Imports(as % of merchandise exports) in Ireland in 1981 to that in 1984?
Make the answer very short. 1.26. What is the ratio of the Imports(as % of merchandise exports) in Macao in 1981 to that in 1984?
Provide a short and direct response. 0.84. What is the ratio of the Imports(as % of merchandise exports) in Sweden in 1981 to that in 1984?
Keep it short and to the point. 1.14. What is the ratio of the Imports(as % of merchandise exports) in Belgium in 1983 to that in 1984?
Provide a short and direct response. 0.95. What is the ratio of the Imports(as % of merchandise exports) of Ireland in 1983 to that in 1984?
Provide a short and direct response. 1.01. What is the ratio of the Imports(as % of merchandise exports) in Macao in 1983 to that in 1984?
Offer a very short reply. 0.94. What is the ratio of the Imports(as % of merchandise exports) of Sweden in 1983 to that in 1984?
Your answer should be compact. 0.89. What is the difference between the highest and the second highest Imports(as % of merchandise exports) of Belgium?
Keep it short and to the point. 0. What is the difference between the highest and the second highest Imports(as % of merchandise exports) of Ireland?
Your response must be concise. 0.01. What is the difference between the highest and the second highest Imports(as % of merchandise exports) of Macao?
Your response must be concise. 16.21. What is the difference between the highest and the second highest Imports(as % of merchandise exports) in Sweden?
Give a very brief answer. 0.2. What is the difference between the highest and the lowest Imports(as % of merchandise exports) of Belgium?
Keep it short and to the point. 0.45. What is the difference between the highest and the lowest Imports(as % of merchandise exports) in Ireland?
Ensure brevity in your answer.  0.85. What is the difference between the highest and the lowest Imports(as % of merchandise exports) of Macao?
Keep it short and to the point. 17.98. What is the difference between the highest and the lowest Imports(as % of merchandise exports) in Sweden?
Your response must be concise. 0.51. 